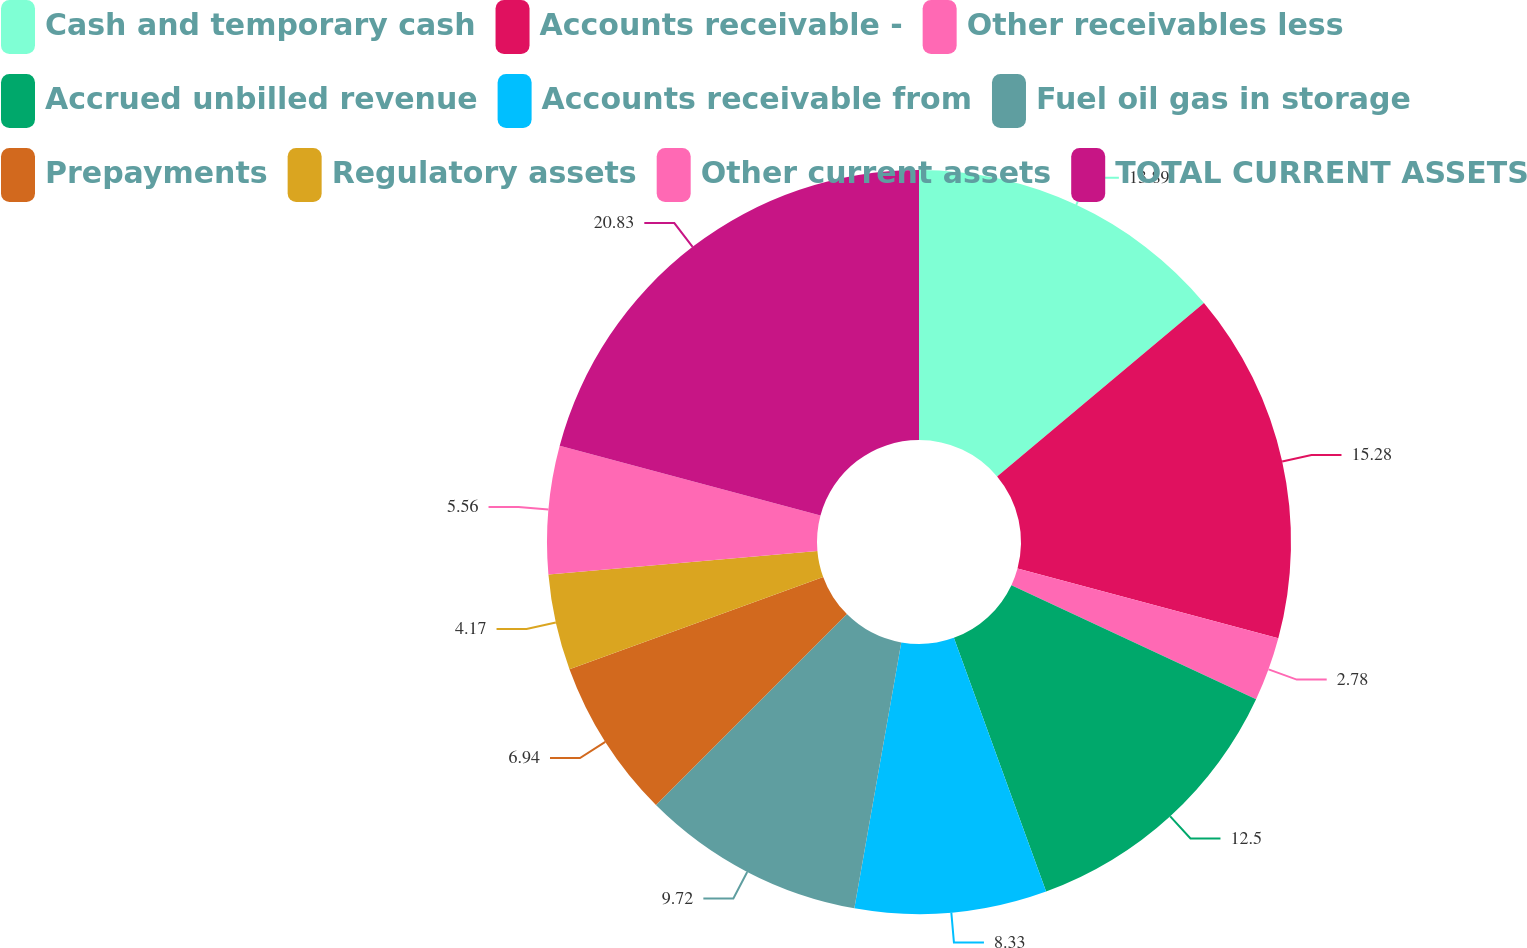Convert chart to OTSL. <chart><loc_0><loc_0><loc_500><loc_500><pie_chart><fcel>Cash and temporary cash<fcel>Accounts receivable -<fcel>Other receivables less<fcel>Accrued unbilled revenue<fcel>Accounts receivable from<fcel>Fuel oil gas in storage<fcel>Prepayments<fcel>Regulatory assets<fcel>Other current assets<fcel>TOTAL CURRENT ASSETS<nl><fcel>13.89%<fcel>15.28%<fcel>2.78%<fcel>12.5%<fcel>8.33%<fcel>9.72%<fcel>6.94%<fcel>4.17%<fcel>5.56%<fcel>20.83%<nl></chart> 